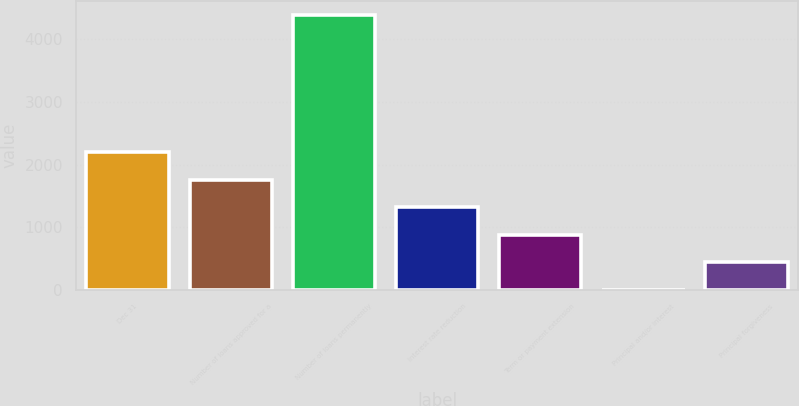Convert chart to OTSL. <chart><loc_0><loc_0><loc_500><loc_500><bar_chart><fcel>Dec 31<fcel>Number of loans approved for a<fcel>Number of loans permanently<fcel>Interest rate reduction<fcel>Term or payment extension<fcel>Principal and/or interest<fcel>Principal forgiveness<nl><fcel>2195.5<fcel>1757.6<fcel>4385<fcel>1319.7<fcel>881.8<fcel>6<fcel>443.9<nl></chart> 